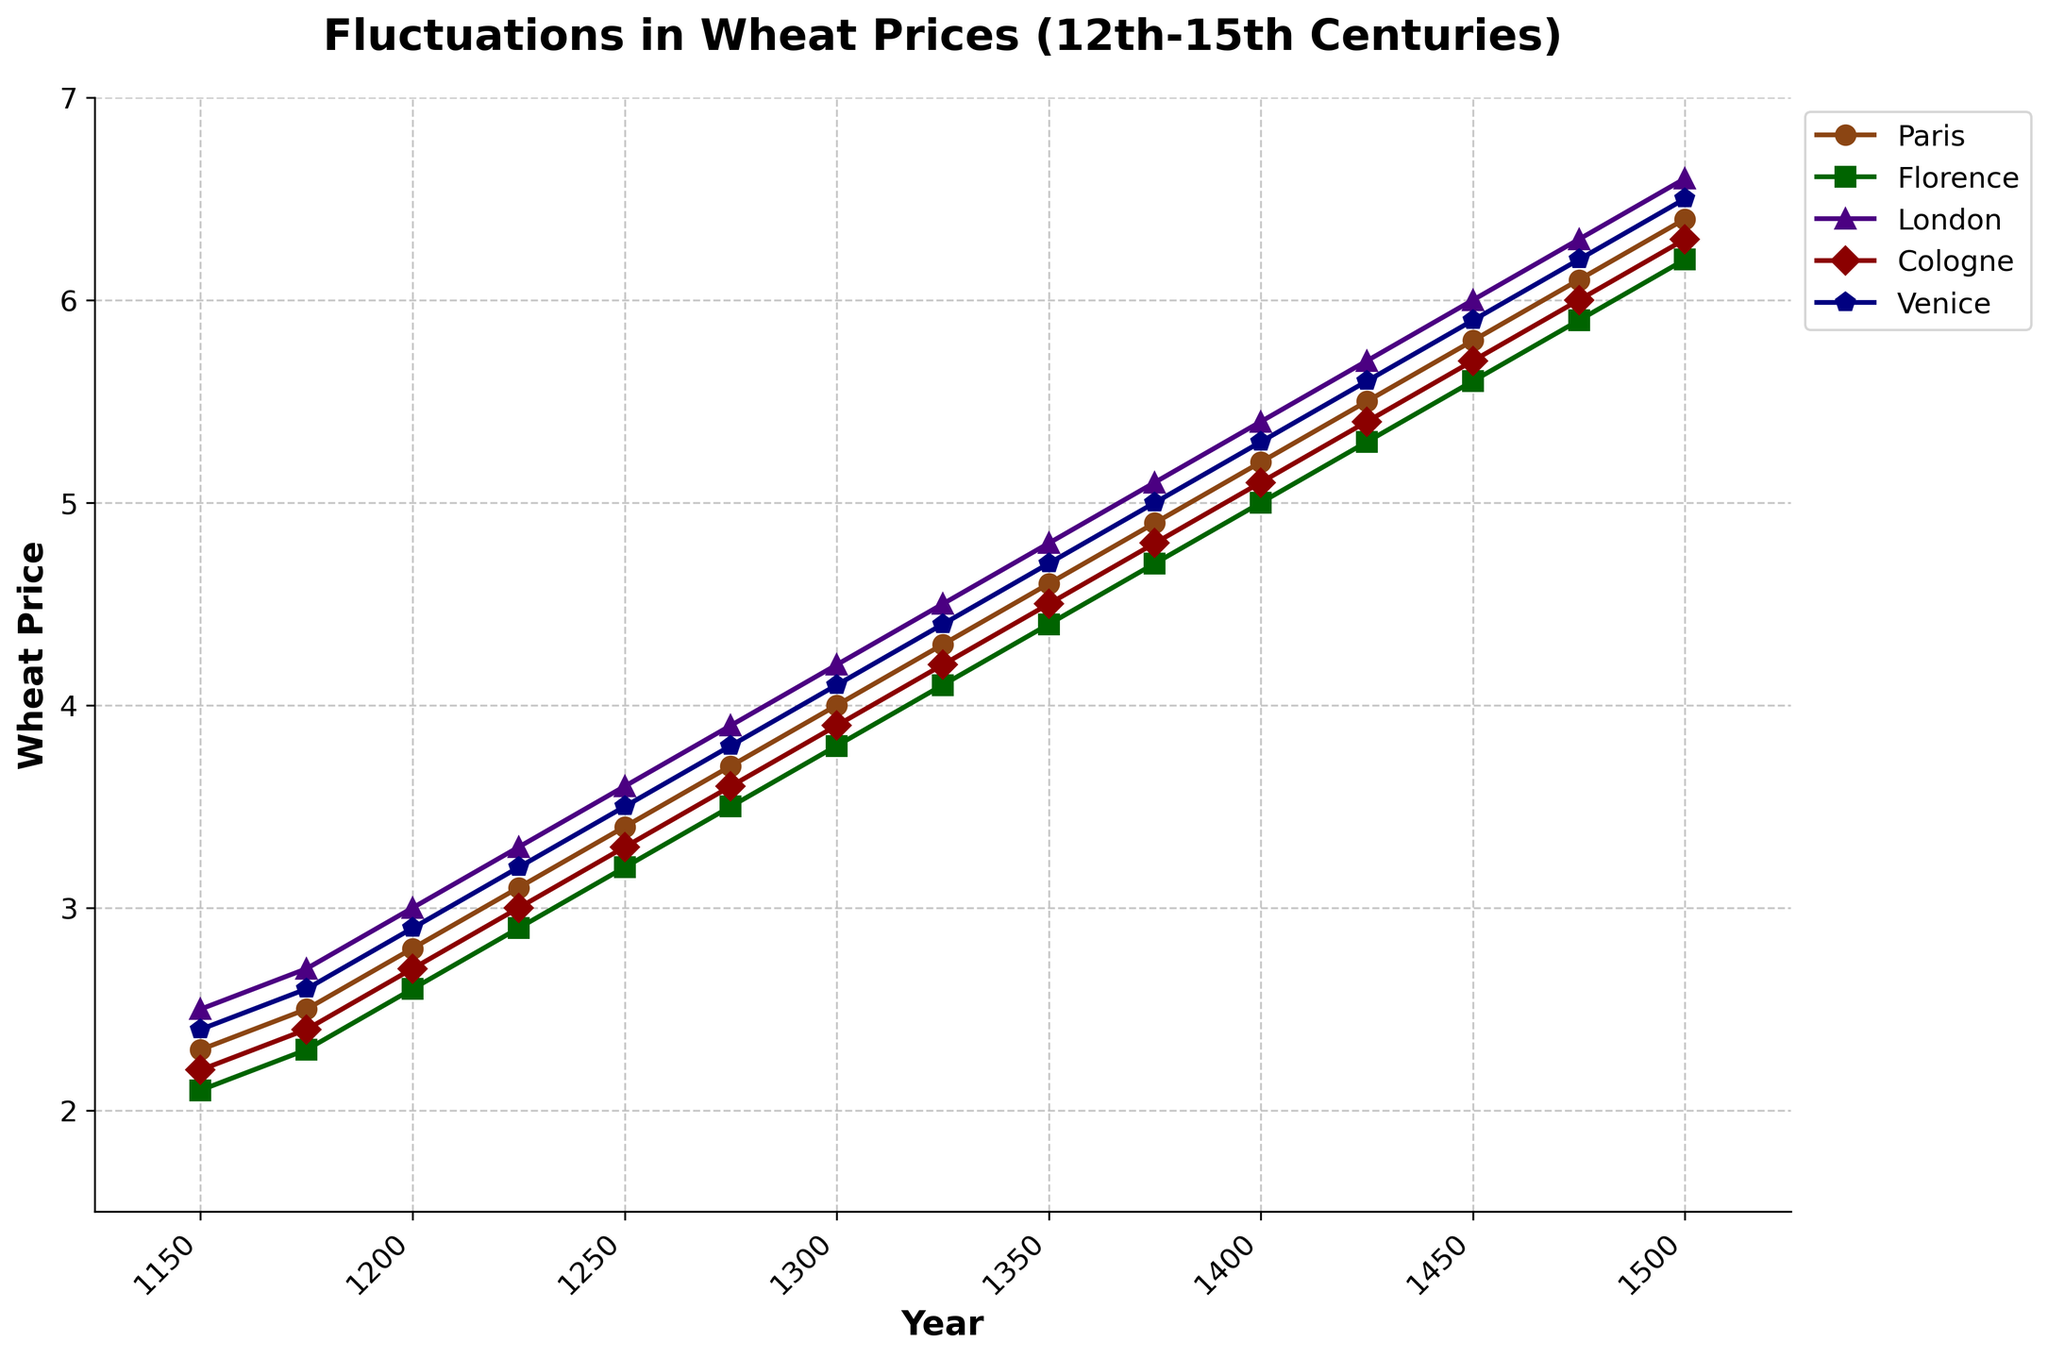What year did wheat prices in Paris first surpass 4.0? According to the figure, we need to find when the Paris wheat price line crosses the 4.0 mark. This happens around the year 1300.
Answer: 1300 In which city was the wheat price highest in the year 1500? Reviewing the graph at the year 1500, the line representing London's wheat price is at the highest point compared to other cities.
Answer: London Between 1300 and 1375, which city experienced the highest rate of increase in wheat prices? To determine this, we compare the slopes of the lines for each city between 1300 and 1375. The steepest slope belongs to London, with an increase from about 4.2 to 5.1.
Answer: London By how much did the price of wheat in Venice increase from 1200 to 1450? The price in Venice at 1200 is 2.9, and by 1450 it is 5.9. The difference is calculated as 5.9 - 2.9 = 3.0.
Answer: 3.0 Which city had the smallest increase in wheat prices from 1150 to 1250? Observing each city’s line from 1150 to 1250, Florence’s increase is the smallest, going from 2.1 to 3.2 which is a difference of 1.1.
Answer: Florence Identify the city with the most stable wheat prices (least volatility) throughout the entire span of years. We assess the lines for all cities to identify which line shows the least fluctuation. Florence's line appears the smoothest with steady increments, indicating the least volatility.
Answer: Florence Between Paris and Cologne, which city had a higher wheat price in 1325, and what was the difference? From the graph, in 1325, Paris had a price of 4.3 and Cologne had 4.2. Thus, Paris had a higher price, and the difference is 4.3 - 4.2 = 0.1.
Answer: Paris, 0.1 What is the average wheat price across all cities in 1250? The prices in 1250 are: Paris (3.4), Florence (3.2), London (3.6), Cologne (3.3), and Venice (3.5). The sum is 3.4 + 3.2 + 3.6 + 3.3 + 3.5 = 17.0, so the average is 17.0 / 5 = 3.4.
Answer: 3.4 